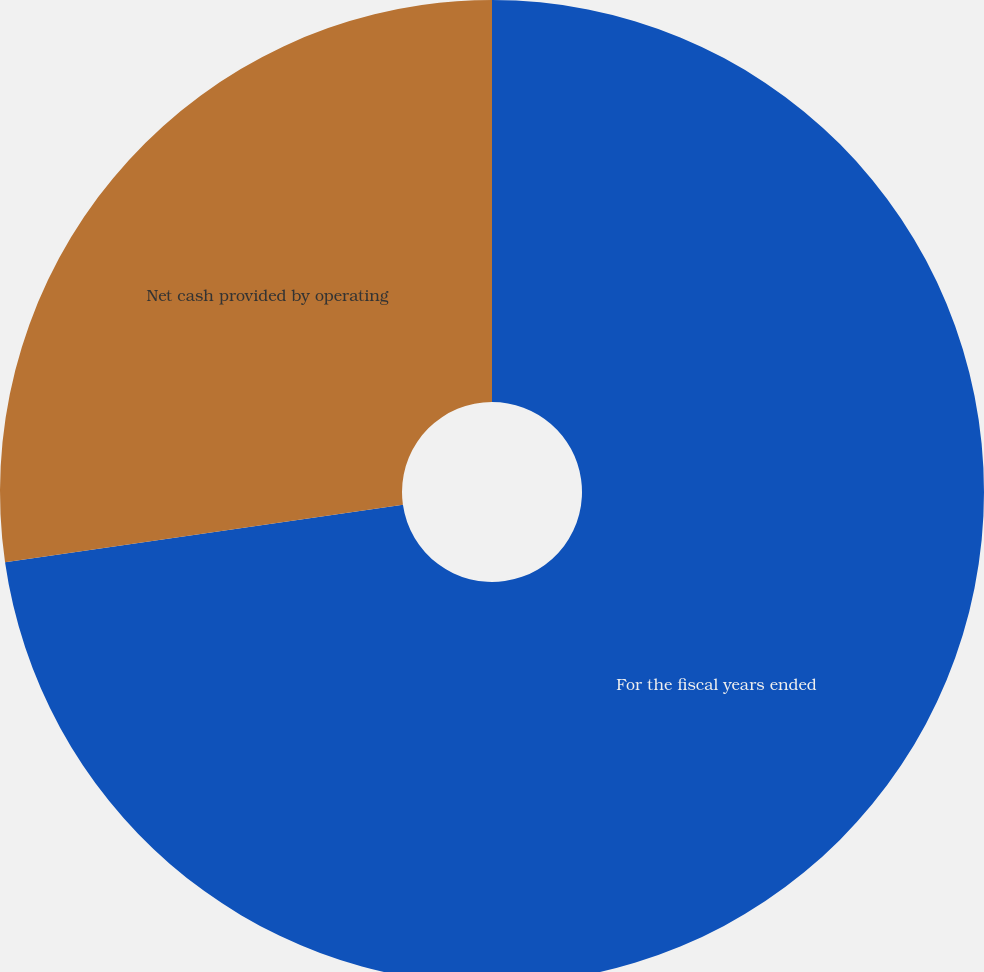Convert chart to OTSL. <chart><loc_0><loc_0><loc_500><loc_500><pie_chart><fcel>For the fiscal years ended<fcel>Net cash provided by operating<nl><fcel>72.72%<fcel>27.28%<nl></chart> 